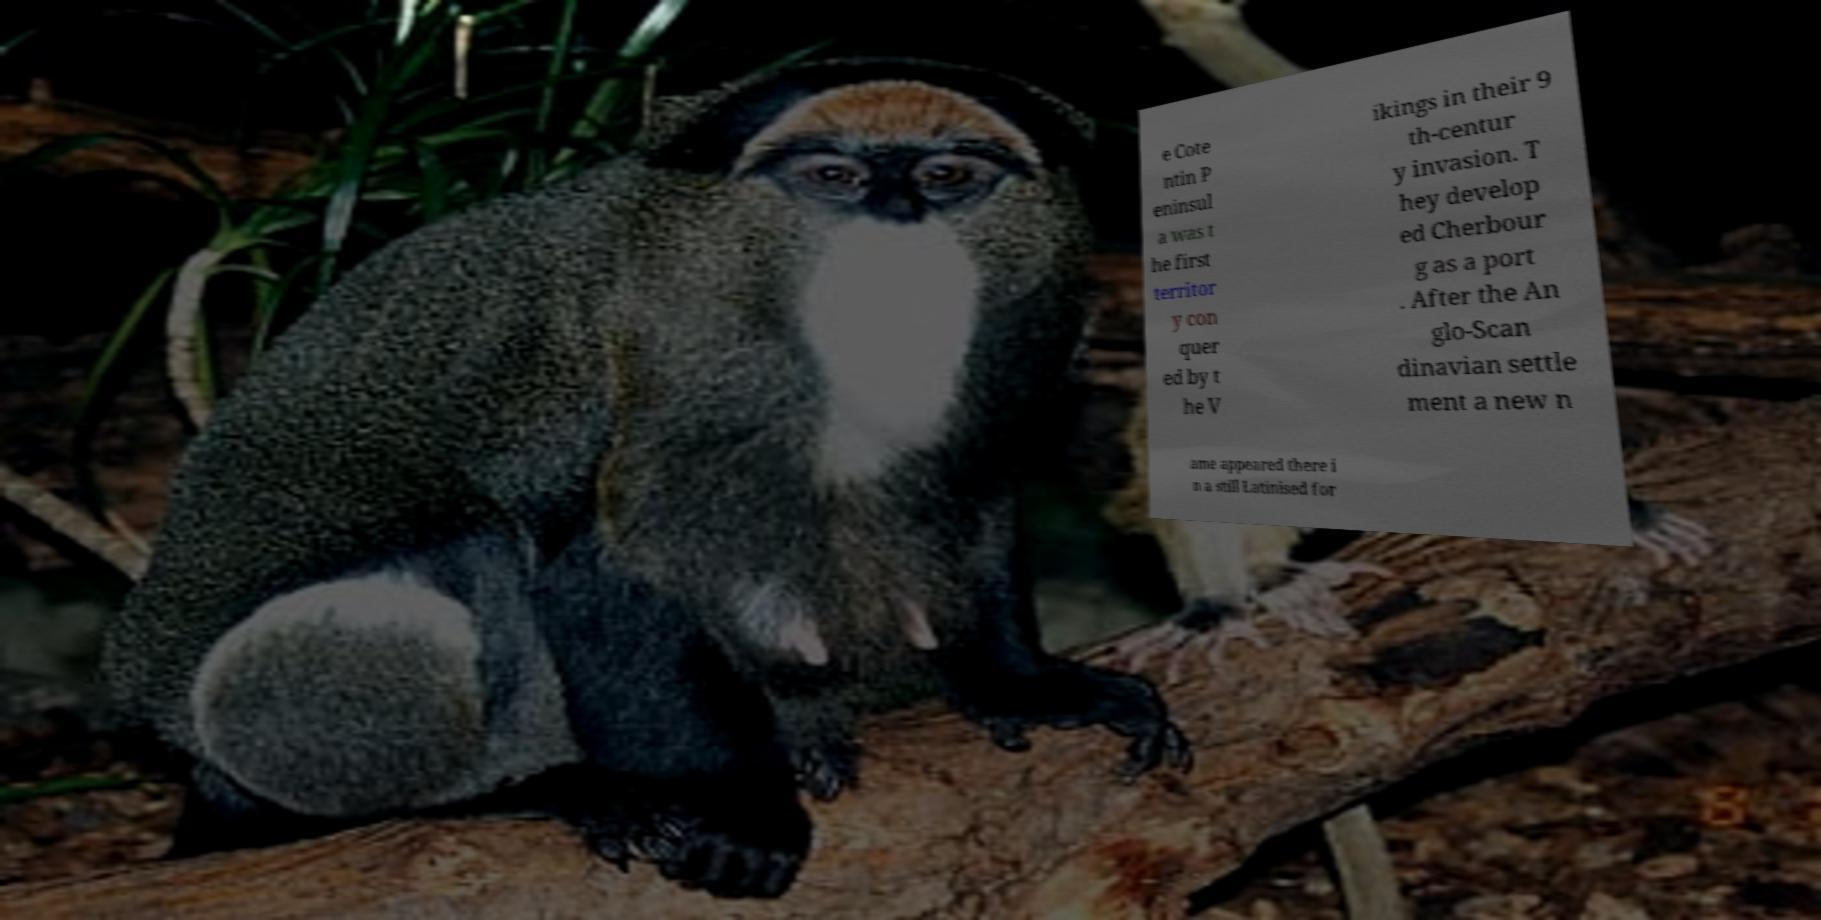Can you read and provide the text displayed in the image?This photo seems to have some interesting text. Can you extract and type it out for me? e Cote ntin P eninsul a was t he first territor y con quer ed by t he V ikings in their 9 th-centur y invasion. T hey develop ed Cherbour g as a port . After the An glo-Scan dinavian settle ment a new n ame appeared there i n a still Latinised for 